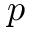Convert formula to latex. <formula><loc_0><loc_0><loc_500><loc_500>p</formula> 